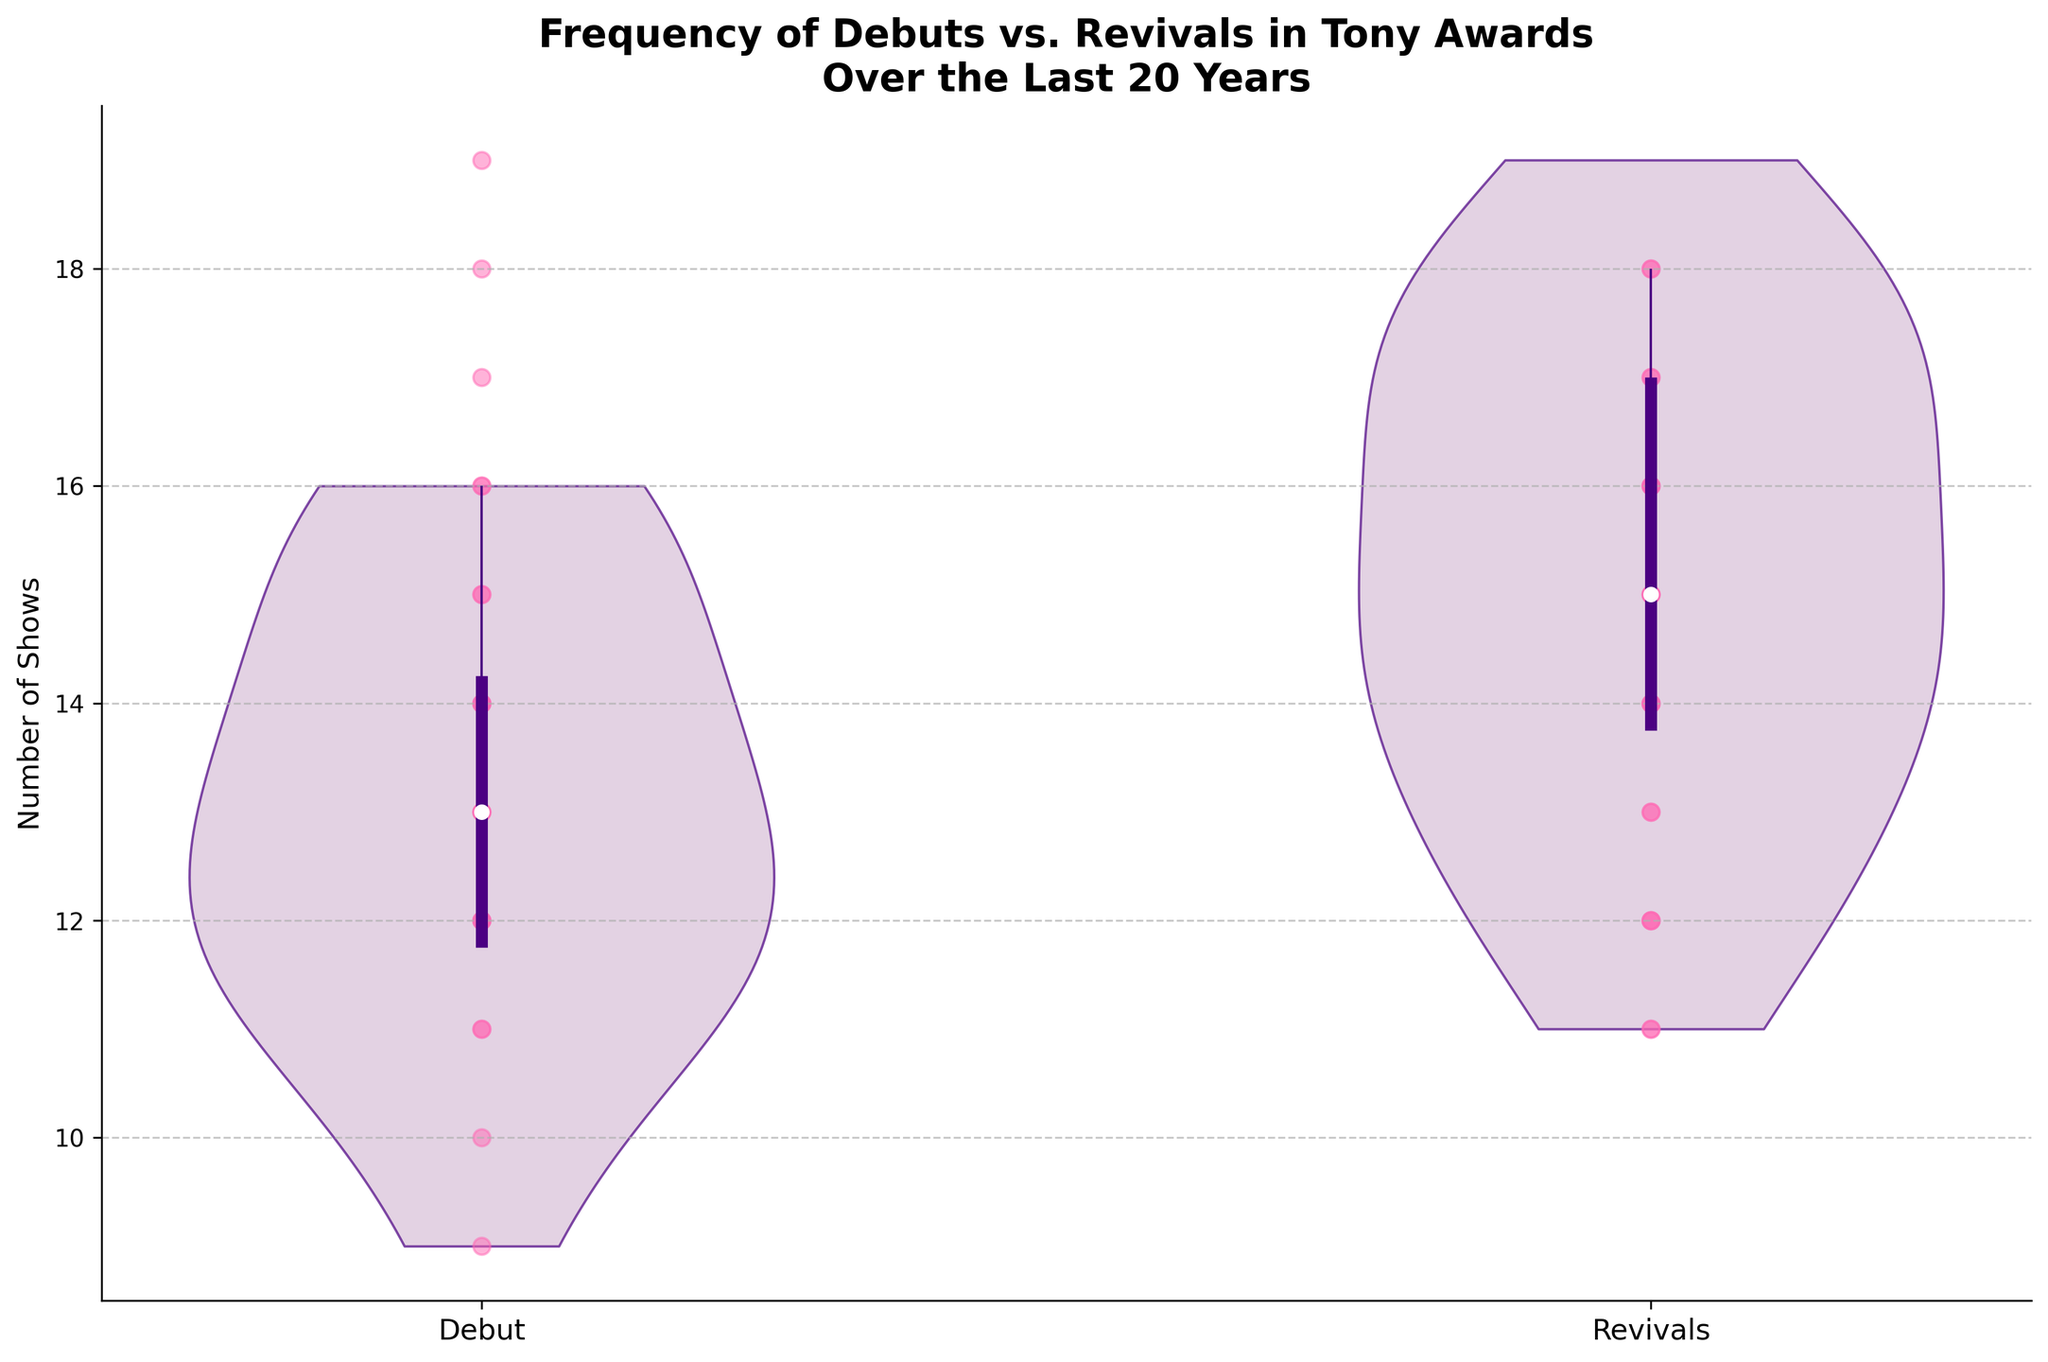What is the title of the plot? The title is clearly stated at the top of the figure, which helps to understand the context of the data being visualized.
Answer: Frequency of Debuts vs. Revivals in Tony Awards Over the Last 20 Years How many categories are compared in the plot? The plot compares two distinct categories, each represented by its own violin and box plot on the figure.
Answer: 2 What is the median frequency of Revivals in the Tony Awards over the last 20 years? The median is represented by a white dot in the center of each box plot. For Revivals, it is the second violin from the left.
Answer: 15 Which category shows a higher median frequency over the last 20 years? By comparing the position of the white median dots in both violins, the category with the higher median can be identified.
Answer: Revivals What is the interquartile range (IQR) for Debuts? The IQR is the length of the box in the box plot. For Debuts (first violin), it’s the range from the first quartile (bottom of the box) to the third quartile (top of the box).
Answer: 3 (11 to 14) What is the maximum adjacent value for Revivals? The maximum adjacent value is indicated by the top whisker of the box plot for Revivals. It's the higher value of the line extending from the top of the box.
Answer: 19 Which category has more variability in their counts? Variability can be visually assessed by the spread of the violins and the length of the whiskers. The wider violin with longer whiskers indicates more variability.
Answer: Revivals Which year had the highest frequency for Debuts? The scatter plot points within the violins reveal individual data points. The highest point within the Debut violin corresponds to the highest frequency year.
Answer: 2005 Compare the whiskers' length of Debuts and Revivals. Which one is longer? The length of the whiskers provides an indication of the spread of data points beyond the interquartile range. The category with longer whiskers has more spread in its data.
Answer: Revivals What is the range of count values for Debuts? The range is the difference between the maximum and minimum values indicated by the extreme points of the whiskers for the Debuts category.
Answer: 9 to 16 